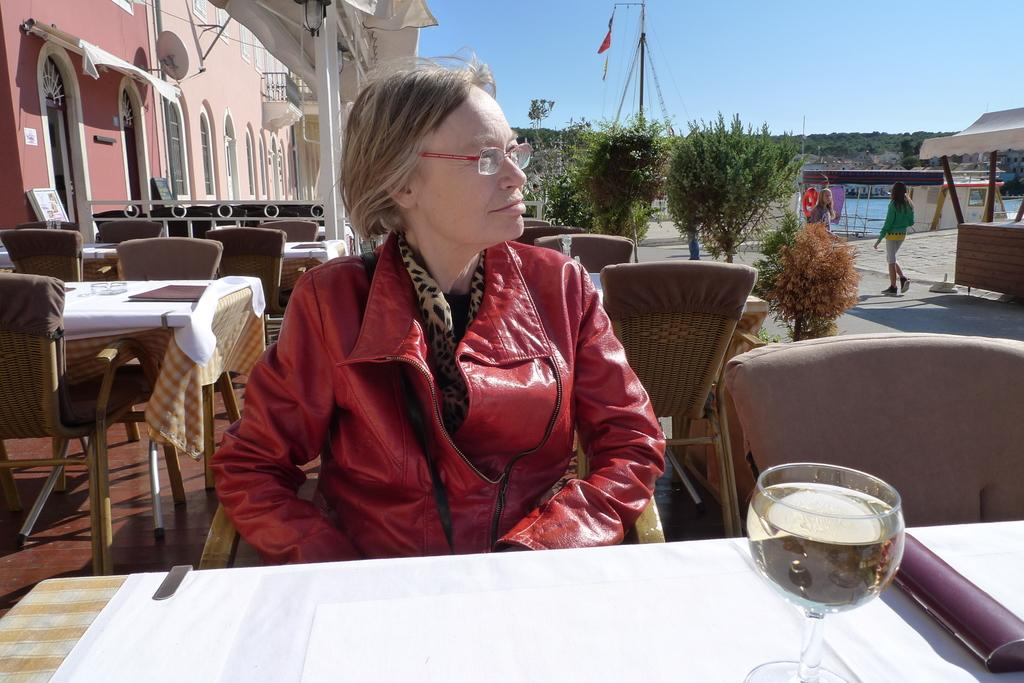What is the woman doing in the image? The woman is sitting on a chair in the image. What is in front of the woman? There is a wine glass in front of the woman. What can be seen in the background of the image? Many trees are visible in the image. What is the color of the sky in the image? The sky is blue in color. What type of fuel is being used by the woman in the image? There is no indication in the image that the woman is using any type of fuel. 